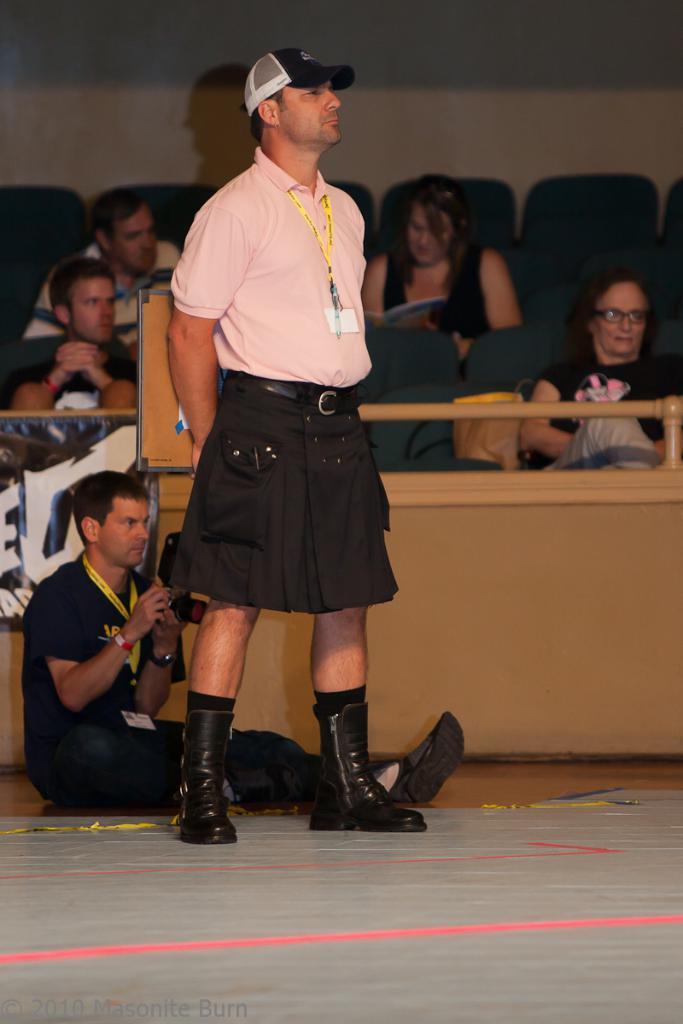Please provide a concise description of this image. This picture shows a man standing and he wore a cap on his head and a id tag on his neck and we see another man seated on the floor holding a camera in his hand and we see few people seated on the chairs and watching. 